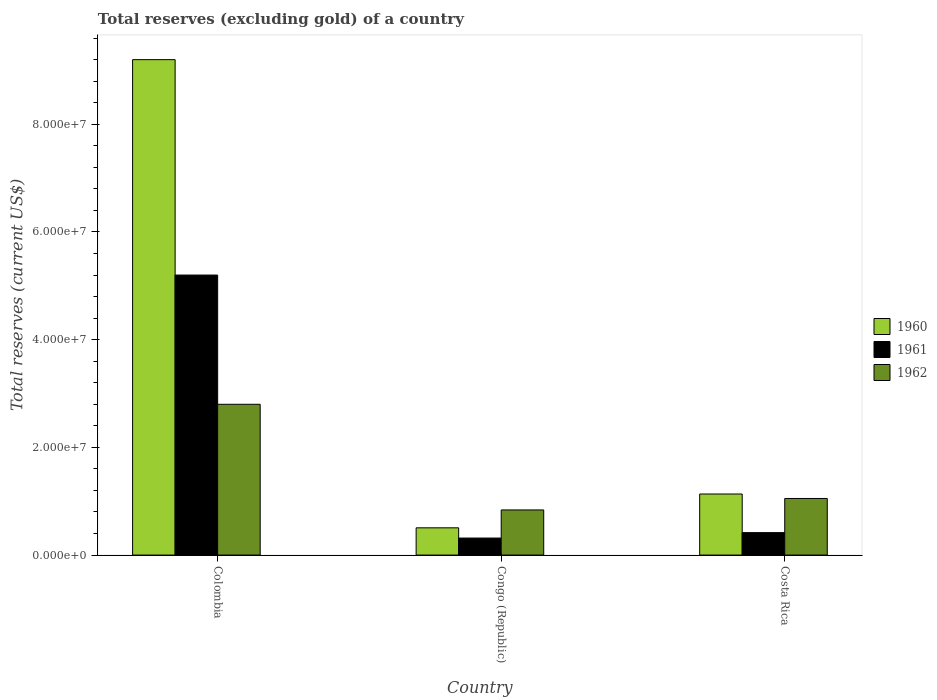How many different coloured bars are there?
Give a very brief answer. 3. How many groups of bars are there?
Give a very brief answer. 3. Are the number of bars on each tick of the X-axis equal?
Keep it short and to the point. Yes. How many bars are there on the 1st tick from the left?
Your response must be concise. 3. What is the label of the 3rd group of bars from the left?
Ensure brevity in your answer.  Costa Rica. In how many cases, is the number of bars for a given country not equal to the number of legend labels?
Give a very brief answer. 0. What is the total reserves (excluding gold) in 1962 in Colombia?
Provide a succinct answer. 2.80e+07. Across all countries, what is the maximum total reserves (excluding gold) in 1962?
Your response must be concise. 2.80e+07. Across all countries, what is the minimum total reserves (excluding gold) in 1961?
Your response must be concise. 3.16e+06. In which country was the total reserves (excluding gold) in 1961 minimum?
Offer a terse response. Congo (Republic). What is the total total reserves (excluding gold) in 1962 in the graph?
Keep it short and to the point. 4.69e+07. What is the difference between the total reserves (excluding gold) in 1962 in Colombia and that in Congo (Republic)?
Offer a terse response. 1.96e+07. What is the difference between the total reserves (excluding gold) in 1961 in Costa Rica and the total reserves (excluding gold) in 1960 in Congo (Republic)?
Your response must be concise. -8.90e+05. What is the average total reserves (excluding gold) in 1961 per country?
Your response must be concise. 1.98e+07. What is the difference between the total reserves (excluding gold) of/in 1962 and total reserves (excluding gold) of/in 1961 in Congo (Republic)?
Provide a short and direct response. 5.22e+06. In how many countries, is the total reserves (excluding gold) in 1960 greater than 52000000 US$?
Offer a very short reply. 1. What is the ratio of the total reserves (excluding gold) in 1961 in Colombia to that in Costa Rica?
Offer a terse response. 12.47. What is the difference between the highest and the second highest total reserves (excluding gold) in 1961?
Your answer should be compact. 4.78e+07. What is the difference between the highest and the lowest total reserves (excluding gold) in 1960?
Your answer should be compact. 8.69e+07. In how many countries, is the total reserves (excluding gold) in 1962 greater than the average total reserves (excluding gold) in 1962 taken over all countries?
Your answer should be very brief. 1. How many countries are there in the graph?
Your answer should be very brief. 3. What is the difference between two consecutive major ticks on the Y-axis?
Your answer should be compact. 2.00e+07. Does the graph contain grids?
Ensure brevity in your answer.  No. How many legend labels are there?
Provide a succinct answer. 3. How are the legend labels stacked?
Make the answer very short. Vertical. What is the title of the graph?
Give a very brief answer. Total reserves (excluding gold) of a country. Does "1998" appear as one of the legend labels in the graph?
Your answer should be very brief. No. What is the label or title of the X-axis?
Your response must be concise. Country. What is the label or title of the Y-axis?
Ensure brevity in your answer.  Total reserves (current US$). What is the Total reserves (current US$) of 1960 in Colombia?
Make the answer very short. 9.20e+07. What is the Total reserves (current US$) in 1961 in Colombia?
Provide a short and direct response. 5.20e+07. What is the Total reserves (current US$) in 1962 in Colombia?
Keep it short and to the point. 2.80e+07. What is the Total reserves (current US$) of 1960 in Congo (Republic)?
Give a very brief answer. 5.06e+06. What is the Total reserves (current US$) of 1961 in Congo (Republic)?
Provide a short and direct response. 3.16e+06. What is the Total reserves (current US$) in 1962 in Congo (Republic)?
Offer a terse response. 8.38e+06. What is the Total reserves (current US$) in 1960 in Costa Rica?
Ensure brevity in your answer.  1.13e+07. What is the Total reserves (current US$) of 1961 in Costa Rica?
Your response must be concise. 4.17e+06. What is the Total reserves (current US$) of 1962 in Costa Rica?
Ensure brevity in your answer.  1.05e+07. Across all countries, what is the maximum Total reserves (current US$) in 1960?
Your answer should be compact. 9.20e+07. Across all countries, what is the maximum Total reserves (current US$) of 1961?
Provide a succinct answer. 5.20e+07. Across all countries, what is the maximum Total reserves (current US$) in 1962?
Offer a very short reply. 2.80e+07. Across all countries, what is the minimum Total reserves (current US$) of 1960?
Provide a succinct answer. 5.06e+06. Across all countries, what is the minimum Total reserves (current US$) in 1961?
Your response must be concise. 3.16e+06. Across all countries, what is the minimum Total reserves (current US$) in 1962?
Your answer should be very brief. 8.38e+06. What is the total Total reserves (current US$) in 1960 in the graph?
Offer a very short reply. 1.08e+08. What is the total Total reserves (current US$) of 1961 in the graph?
Offer a terse response. 5.93e+07. What is the total Total reserves (current US$) in 1962 in the graph?
Give a very brief answer. 4.69e+07. What is the difference between the Total reserves (current US$) of 1960 in Colombia and that in Congo (Republic)?
Offer a very short reply. 8.69e+07. What is the difference between the Total reserves (current US$) of 1961 in Colombia and that in Congo (Republic)?
Provide a succinct answer. 4.88e+07. What is the difference between the Total reserves (current US$) of 1962 in Colombia and that in Congo (Republic)?
Make the answer very short. 1.96e+07. What is the difference between the Total reserves (current US$) in 1960 in Colombia and that in Costa Rica?
Provide a succinct answer. 8.07e+07. What is the difference between the Total reserves (current US$) of 1961 in Colombia and that in Costa Rica?
Your answer should be compact. 4.78e+07. What is the difference between the Total reserves (current US$) of 1962 in Colombia and that in Costa Rica?
Your response must be concise. 1.75e+07. What is the difference between the Total reserves (current US$) of 1960 in Congo (Republic) and that in Costa Rica?
Provide a short and direct response. -6.28e+06. What is the difference between the Total reserves (current US$) in 1961 in Congo (Republic) and that in Costa Rica?
Keep it short and to the point. -1.01e+06. What is the difference between the Total reserves (current US$) in 1962 in Congo (Republic) and that in Costa Rica?
Give a very brief answer. -2.13e+06. What is the difference between the Total reserves (current US$) in 1960 in Colombia and the Total reserves (current US$) in 1961 in Congo (Republic)?
Your response must be concise. 8.88e+07. What is the difference between the Total reserves (current US$) of 1960 in Colombia and the Total reserves (current US$) of 1962 in Congo (Republic)?
Offer a very short reply. 8.36e+07. What is the difference between the Total reserves (current US$) of 1961 in Colombia and the Total reserves (current US$) of 1962 in Congo (Republic)?
Your answer should be compact. 4.36e+07. What is the difference between the Total reserves (current US$) of 1960 in Colombia and the Total reserves (current US$) of 1961 in Costa Rica?
Keep it short and to the point. 8.78e+07. What is the difference between the Total reserves (current US$) of 1960 in Colombia and the Total reserves (current US$) of 1962 in Costa Rica?
Your answer should be very brief. 8.15e+07. What is the difference between the Total reserves (current US$) of 1961 in Colombia and the Total reserves (current US$) of 1962 in Costa Rica?
Your answer should be compact. 4.15e+07. What is the difference between the Total reserves (current US$) of 1960 in Congo (Republic) and the Total reserves (current US$) of 1961 in Costa Rica?
Your answer should be very brief. 8.90e+05. What is the difference between the Total reserves (current US$) in 1960 in Congo (Republic) and the Total reserves (current US$) in 1962 in Costa Rica?
Your answer should be very brief. -5.45e+06. What is the difference between the Total reserves (current US$) of 1961 in Congo (Republic) and the Total reserves (current US$) of 1962 in Costa Rica?
Give a very brief answer. -7.35e+06. What is the average Total reserves (current US$) of 1960 per country?
Your response must be concise. 3.61e+07. What is the average Total reserves (current US$) of 1961 per country?
Keep it short and to the point. 1.98e+07. What is the average Total reserves (current US$) of 1962 per country?
Offer a very short reply. 1.56e+07. What is the difference between the Total reserves (current US$) of 1960 and Total reserves (current US$) of 1961 in Colombia?
Your response must be concise. 4.00e+07. What is the difference between the Total reserves (current US$) in 1960 and Total reserves (current US$) in 1962 in Colombia?
Provide a succinct answer. 6.40e+07. What is the difference between the Total reserves (current US$) of 1961 and Total reserves (current US$) of 1962 in Colombia?
Your answer should be compact. 2.40e+07. What is the difference between the Total reserves (current US$) in 1960 and Total reserves (current US$) in 1961 in Congo (Republic)?
Offer a terse response. 1.90e+06. What is the difference between the Total reserves (current US$) of 1960 and Total reserves (current US$) of 1962 in Congo (Republic)?
Your answer should be very brief. -3.32e+06. What is the difference between the Total reserves (current US$) in 1961 and Total reserves (current US$) in 1962 in Congo (Republic)?
Make the answer very short. -5.22e+06. What is the difference between the Total reserves (current US$) in 1960 and Total reserves (current US$) in 1961 in Costa Rica?
Offer a terse response. 7.17e+06. What is the difference between the Total reserves (current US$) of 1960 and Total reserves (current US$) of 1962 in Costa Rica?
Ensure brevity in your answer.  8.30e+05. What is the difference between the Total reserves (current US$) of 1961 and Total reserves (current US$) of 1962 in Costa Rica?
Offer a very short reply. -6.34e+06. What is the ratio of the Total reserves (current US$) in 1960 in Colombia to that in Congo (Republic)?
Keep it short and to the point. 18.18. What is the ratio of the Total reserves (current US$) in 1961 in Colombia to that in Congo (Republic)?
Provide a succinct answer. 16.46. What is the ratio of the Total reserves (current US$) of 1962 in Colombia to that in Congo (Republic)?
Provide a succinct answer. 3.34. What is the ratio of the Total reserves (current US$) of 1960 in Colombia to that in Costa Rica?
Provide a short and direct response. 8.11. What is the ratio of the Total reserves (current US$) in 1961 in Colombia to that in Costa Rica?
Ensure brevity in your answer.  12.47. What is the ratio of the Total reserves (current US$) of 1962 in Colombia to that in Costa Rica?
Keep it short and to the point. 2.66. What is the ratio of the Total reserves (current US$) of 1960 in Congo (Republic) to that in Costa Rica?
Give a very brief answer. 0.45. What is the ratio of the Total reserves (current US$) of 1961 in Congo (Republic) to that in Costa Rica?
Your answer should be compact. 0.76. What is the ratio of the Total reserves (current US$) of 1962 in Congo (Republic) to that in Costa Rica?
Give a very brief answer. 0.8. What is the difference between the highest and the second highest Total reserves (current US$) of 1960?
Make the answer very short. 8.07e+07. What is the difference between the highest and the second highest Total reserves (current US$) in 1961?
Keep it short and to the point. 4.78e+07. What is the difference between the highest and the second highest Total reserves (current US$) in 1962?
Make the answer very short. 1.75e+07. What is the difference between the highest and the lowest Total reserves (current US$) in 1960?
Ensure brevity in your answer.  8.69e+07. What is the difference between the highest and the lowest Total reserves (current US$) in 1961?
Your answer should be compact. 4.88e+07. What is the difference between the highest and the lowest Total reserves (current US$) of 1962?
Provide a short and direct response. 1.96e+07. 